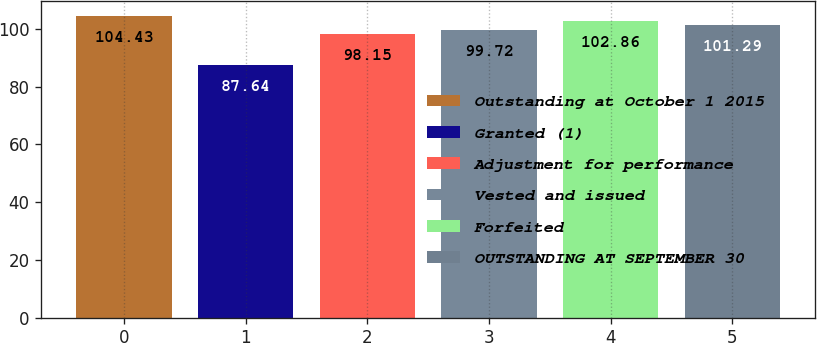Convert chart to OTSL. <chart><loc_0><loc_0><loc_500><loc_500><bar_chart><fcel>Outstanding at October 1 2015<fcel>Granted (1)<fcel>Adjustment for performance<fcel>Vested and issued<fcel>Forfeited<fcel>OUTSTANDING AT SEPTEMBER 30<nl><fcel>104.43<fcel>87.64<fcel>98.15<fcel>99.72<fcel>102.86<fcel>101.29<nl></chart> 